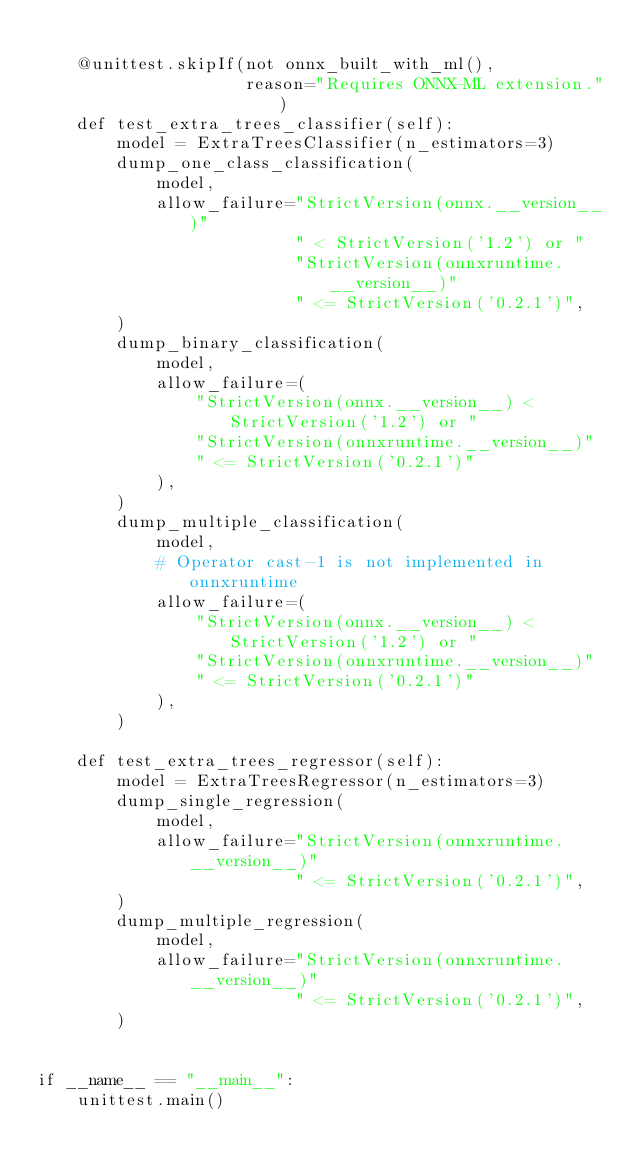<code> <loc_0><loc_0><loc_500><loc_500><_Python_>
    @unittest.skipIf(not onnx_built_with_ml(),
                     reason="Requires ONNX-ML extension.")
    def test_extra_trees_classifier(self):
        model = ExtraTreesClassifier(n_estimators=3)
        dump_one_class_classification(
            model,
            allow_failure="StrictVersion(onnx.__version__)"
                          " < StrictVersion('1.2') or "
                          "StrictVersion(onnxruntime.__version__)"
                          " <= StrictVersion('0.2.1')",
        )
        dump_binary_classification(
            model,
            allow_failure=(
                "StrictVersion(onnx.__version__) < StrictVersion('1.2') or "
                "StrictVersion(onnxruntime.__version__)"
                " <= StrictVersion('0.2.1')"
            ),
        )
        dump_multiple_classification(
            model,
            # Operator cast-1 is not implemented in onnxruntime
            allow_failure=(
                "StrictVersion(onnx.__version__) < StrictVersion('1.2') or "
                "StrictVersion(onnxruntime.__version__)"
                " <= StrictVersion('0.2.1')"
            ),
        )

    def test_extra_trees_regressor(self):
        model = ExtraTreesRegressor(n_estimators=3)
        dump_single_regression(
            model,
            allow_failure="StrictVersion(onnxruntime.__version__)"
                          " <= StrictVersion('0.2.1')",
        )
        dump_multiple_regression(
            model,
            allow_failure="StrictVersion(onnxruntime.__version__)"
                          " <= StrictVersion('0.2.1')",
        )


if __name__ == "__main__":
    unittest.main()
</code> 